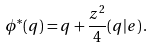Convert formula to latex. <formula><loc_0><loc_0><loc_500><loc_500>\phi ^ { * } ( q ) = q + \frac { z ^ { 2 } } { 4 } ( q | e ) \, .</formula> 